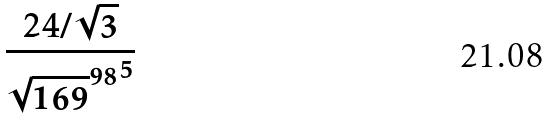Convert formula to latex. <formula><loc_0><loc_0><loc_500><loc_500>\frac { 2 4 / \sqrt { 3 } } { { \sqrt { 1 6 9 } ^ { 9 8 } } ^ { 5 } }</formula> 